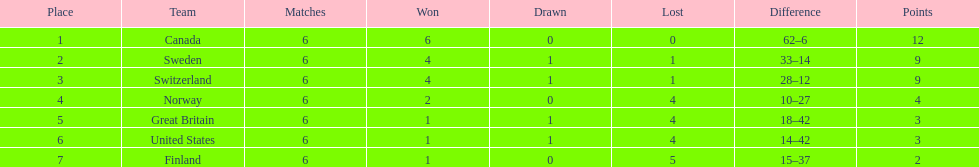During the 1951 world ice hockey championships, what was the difference between the first and last place teams for number of games won ? 5. 